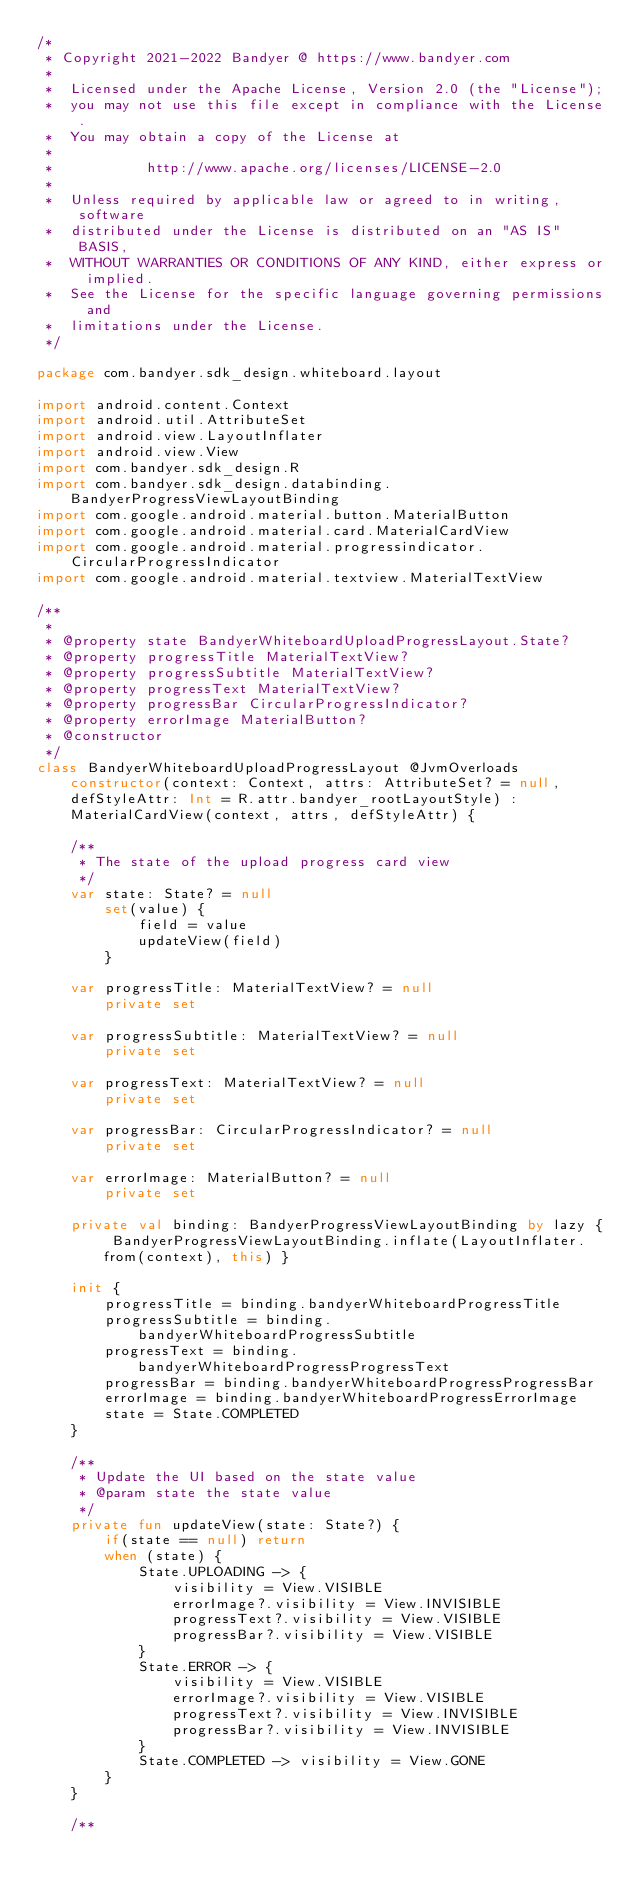<code> <loc_0><loc_0><loc_500><loc_500><_Kotlin_>/*
 * Copyright 2021-2022 Bandyer @ https://www.bandyer.com
 *
 *  Licensed under the Apache License, Version 2.0 (the "License");
 *  you may not use this file except in compliance with the License.
 *  You may obtain a copy of the License at
 *
 *           http://www.apache.org/licenses/LICENSE-2.0
 *
 *  Unless required by applicable law or agreed to in writing, software
 *  distributed under the License is distributed on an "AS IS" BASIS,
 *  WITHOUT WARRANTIES OR CONDITIONS OF ANY KIND, either express or implied.
 *  See the License for the specific language governing permissions and
 *  limitations under the License.
 */

package com.bandyer.sdk_design.whiteboard.layout

import android.content.Context
import android.util.AttributeSet
import android.view.LayoutInflater
import android.view.View
import com.bandyer.sdk_design.R
import com.bandyer.sdk_design.databinding.BandyerProgressViewLayoutBinding
import com.google.android.material.button.MaterialButton
import com.google.android.material.card.MaterialCardView
import com.google.android.material.progressindicator.CircularProgressIndicator
import com.google.android.material.textview.MaterialTextView

/**
 *
 * @property state BandyerWhiteboardUploadProgressLayout.State?
 * @property progressTitle MaterialTextView?
 * @property progressSubtitle MaterialTextView?
 * @property progressText MaterialTextView?
 * @property progressBar CircularProgressIndicator?
 * @property errorImage MaterialButton?
 * @constructor
 */
class BandyerWhiteboardUploadProgressLayout @JvmOverloads constructor(context: Context, attrs: AttributeSet? = null, defStyleAttr: Int = R.attr.bandyer_rootLayoutStyle) : MaterialCardView(context, attrs, defStyleAttr) {

    /**
     * The state of the upload progress card view
     */
    var state: State? = null
        set(value) {
            field = value
            updateView(field)
        }

    var progressTitle: MaterialTextView? = null
        private set

    var progressSubtitle: MaterialTextView? = null
        private set

    var progressText: MaterialTextView? = null
        private set

    var progressBar: CircularProgressIndicator? = null
        private set

    var errorImage: MaterialButton? = null
        private set

    private val binding: BandyerProgressViewLayoutBinding by lazy { BandyerProgressViewLayoutBinding.inflate(LayoutInflater.from(context), this) }

    init {
        progressTitle = binding.bandyerWhiteboardProgressTitle
        progressSubtitle = binding.bandyerWhiteboardProgressSubtitle
        progressText = binding.bandyerWhiteboardProgressProgressText
        progressBar = binding.bandyerWhiteboardProgressProgressBar
        errorImage = binding.bandyerWhiteboardProgressErrorImage
        state = State.COMPLETED
    }

    /**
     * Update the UI based on the state value
     * @param state the state value
     */
    private fun updateView(state: State?) {
        if(state == null) return
        when (state) {
            State.UPLOADING -> {
                visibility = View.VISIBLE
                errorImage?.visibility = View.INVISIBLE
                progressText?.visibility = View.VISIBLE
                progressBar?.visibility = View.VISIBLE
            }
            State.ERROR -> {
                visibility = View.VISIBLE
                errorImage?.visibility = View.VISIBLE
                progressText?.visibility = View.INVISIBLE
                progressBar?.visibility = View.INVISIBLE
            }
            State.COMPLETED -> visibility = View.GONE
        }
    }

    /**</code> 